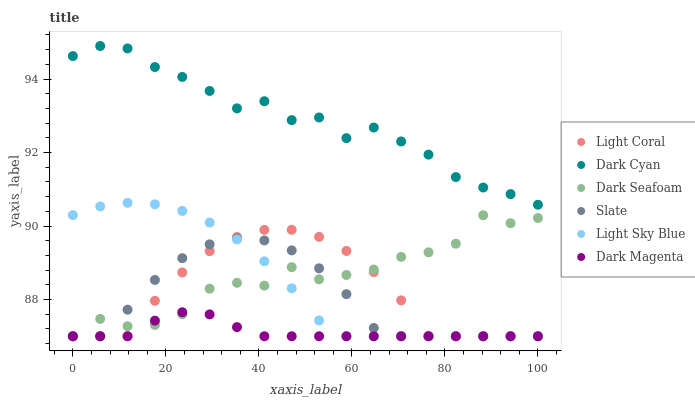Does Dark Magenta have the minimum area under the curve?
Answer yes or no. Yes. Does Dark Cyan have the maximum area under the curve?
Answer yes or no. Yes. Does Slate have the minimum area under the curve?
Answer yes or no. No. Does Slate have the maximum area under the curve?
Answer yes or no. No. Is Dark Magenta the smoothest?
Answer yes or no. Yes. Is Dark Seafoam the roughest?
Answer yes or no. Yes. Is Slate the smoothest?
Answer yes or no. No. Is Slate the roughest?
Answer yes or no. No. Does Dark Magenta have the lowest value?
Answer yes or no. Yes. Does Dark Cyan have the lowest value?
Answer yes or no. No. Does Dark Cyan have the highest value?
Answer yes or no. Yes. Does Slate have the highest value?
Answer yes or no. No. Is Slate less than Dark Cyan?
Answer yes or no. Yes. Is Dark Cyan greater than Dark Magenta?
Answer yes or no. Yes. Does Dark Seafoam intersect Slate?
Answer yes or no. Yes. Is Dark Seafoam less than Slate?
Answer yes or no. No. Is Dark Seafoam greater than Slate?
Answer yes or no. No. Does Slate intersect Dark Cyan?
Answer yes or no. No. 